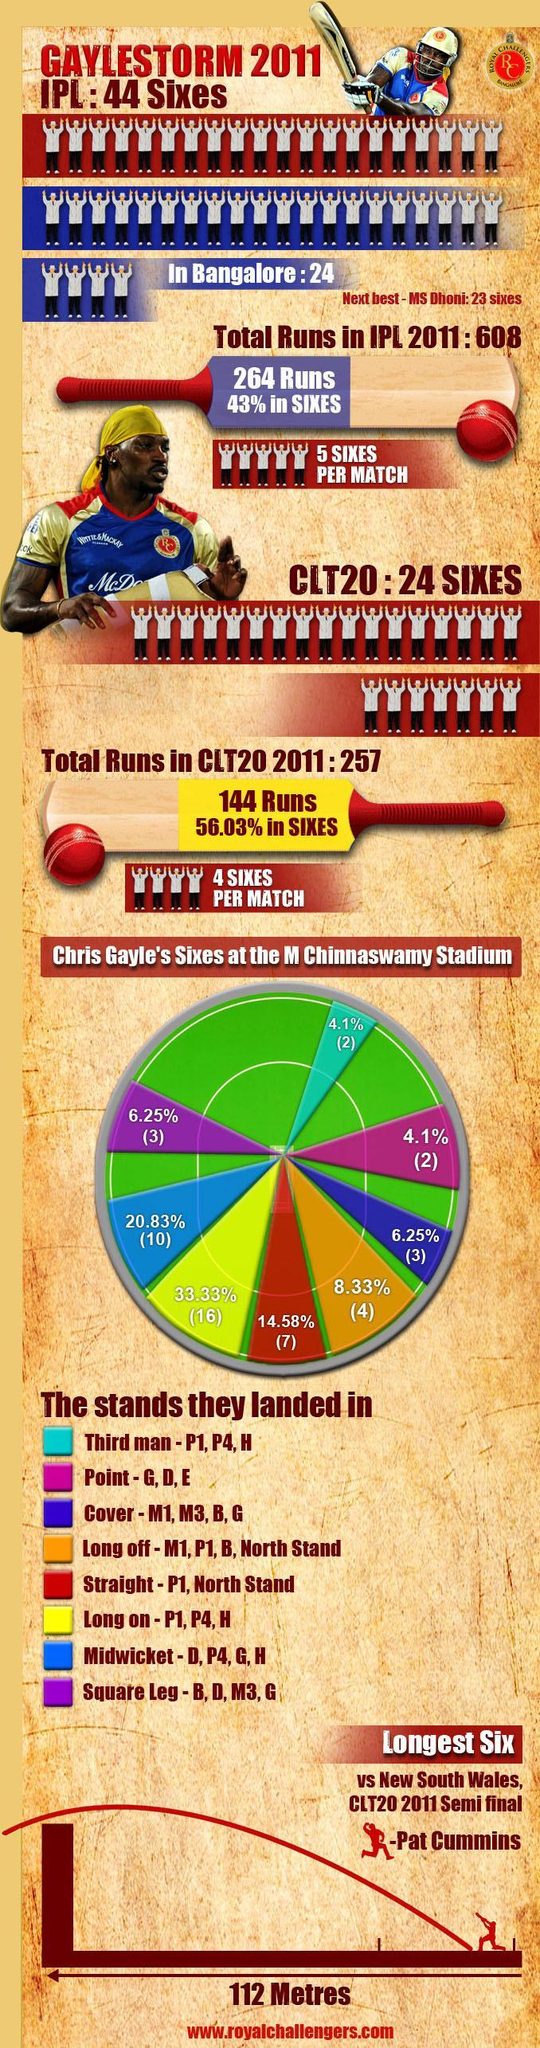Longest six of GayleStorm against which bowler?
Answer the question with a short phrase. Pat Cummins How many sixes in Midwicket? 10 Who has the second-highest record of sixes in IPL? MS Dhoni Straight sixes constitute what percentage of total sixes? 14.58% How many sixes in Square Leg? 3 How many straight sixes? 7 